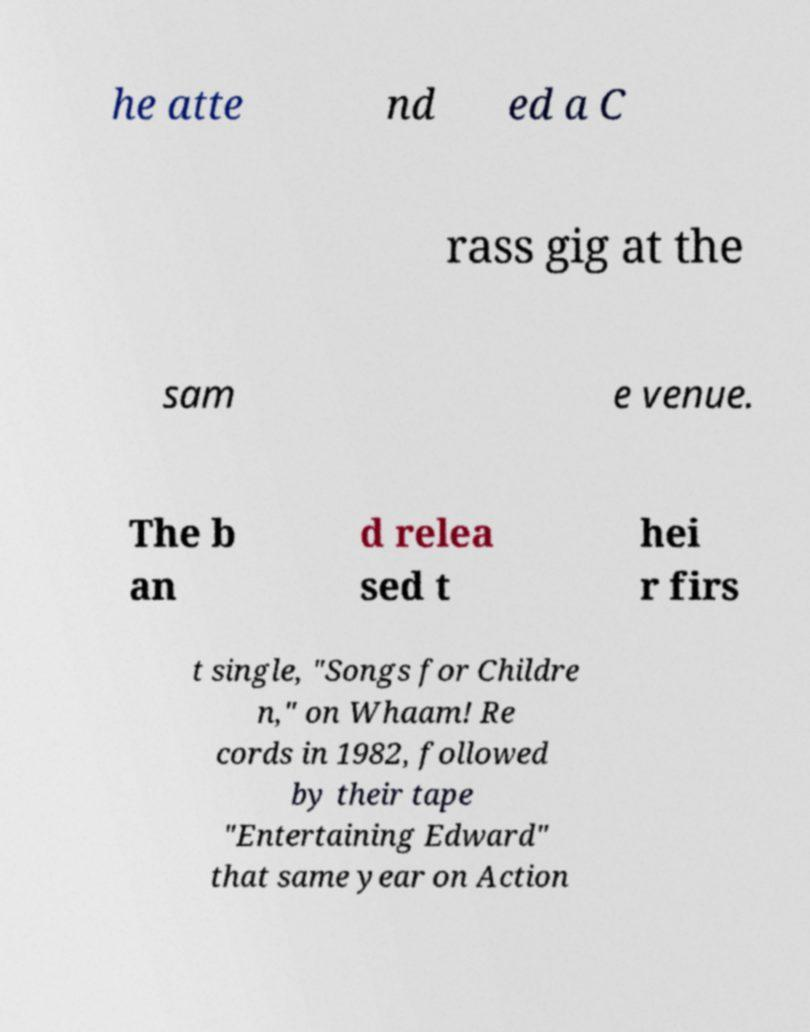Please identify and transcribe the text found in this image. he atte nd ed a C rass gig at the sam e venue. The b an d relea sed t hei r firs t single, "Songs for Childre n," on Whaam! Re cords in 1982, followed by their tape "Entertaining Edward" that same year on Action 